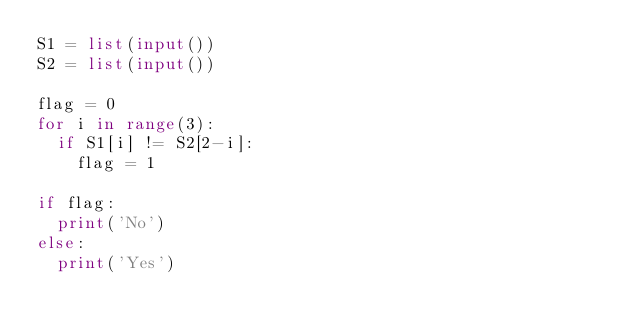<code> <loc_0><loc_0><loc_500><loc_500><_Python_>S1 = list(input())
S2 = list(input())

flag = 0
for i in range(3):
  if S1[i] != S2[2-i]:
    flag = 1

if flag:
  print('No')
else:
  print('Yes')</code> 